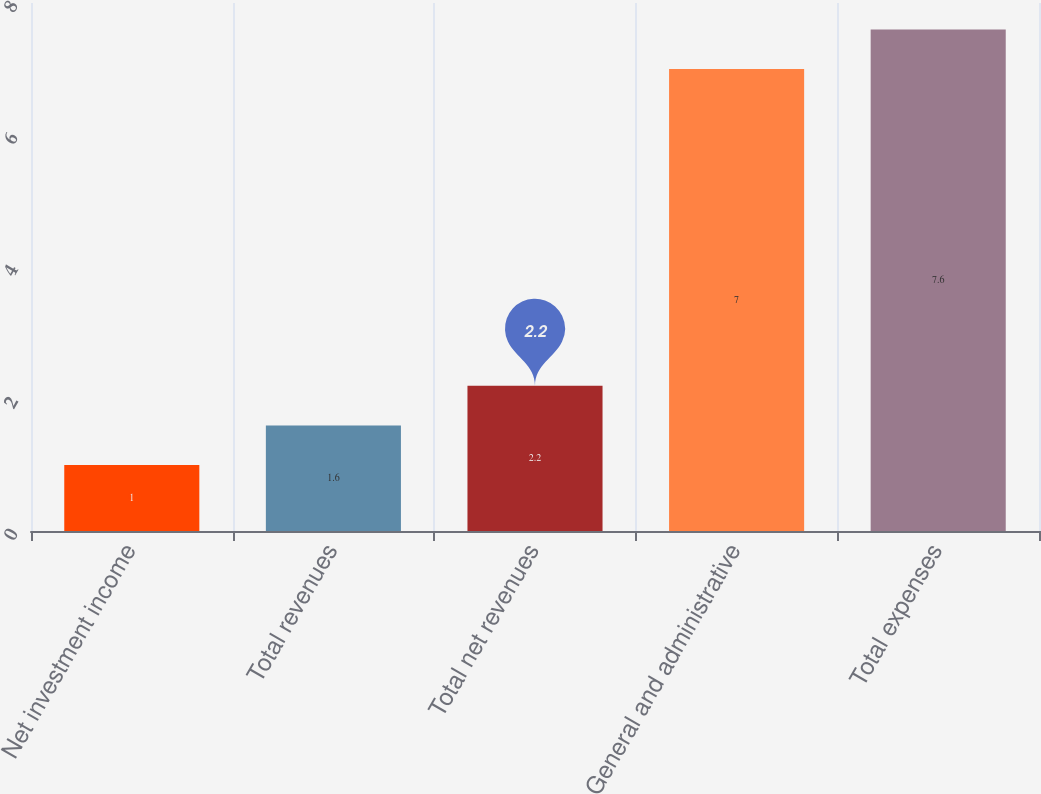<chart> <loc_0><loc_0><loc_500><loc_500><bar_chart><fcel>Net investment income<fcel>Total revenues<fcel>Total net revenues<fcel>General and administrative<fcel>Total expenses<nl><fcel>1<fcel>1.6<fcel>2.2<fcel>7<fcel>7.6<nl></chart> 